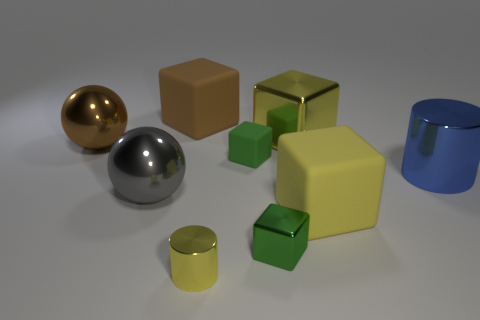There is a cylinder that is the same size as the brown ball; what is its material?
Your answer should be very brief. Metal. Are there any brown balls that have the same size as the yellow cylinder?
Your answer should be compact. No. There is a metal cube in front of the brown metallic sphere; what is its color?
Offer a very short reply. Green. There is a yellow metal object that is in front of the big yellow metallic cube; are there any tiny green cubes that are in front of it?
Make the answer very short. No. What number of other objects are there of the same color as the large shiny cylinder?
Make the answer very short. 0. There is a gray object in front of the blue thing; is its size the same as the cylinder that is on the left side of the big yellow rubber cube?
Keep it short and to the point. No. What size is the brown block that is behind the tiny object to the right of the small matte thing?
Make the answer very short. Large. What material is the large cube that is both to the right of the tiny green shiny block and behind the large brown metallic thing?
Make the answer very short. Metal. What color is the small rubber object?
Provide a succinct answer. Green. Is there anything else that is made of the same material as the big gray sphere?
Offer a very short reply. Yes. 